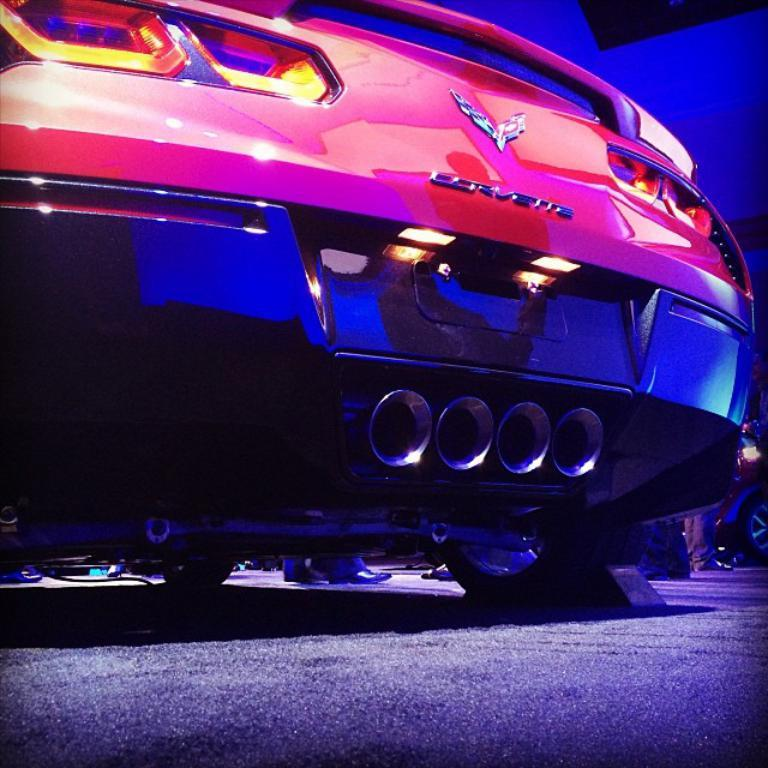What is the main object in the image? There is a car in the image. Where is the car located? The car is on the floor. Can you describe the background of the image? The background of the image has blue and black colors. What type of soup is being served in the car? There is no soup present in the image; it features a car on the floor with a blue and black background. 